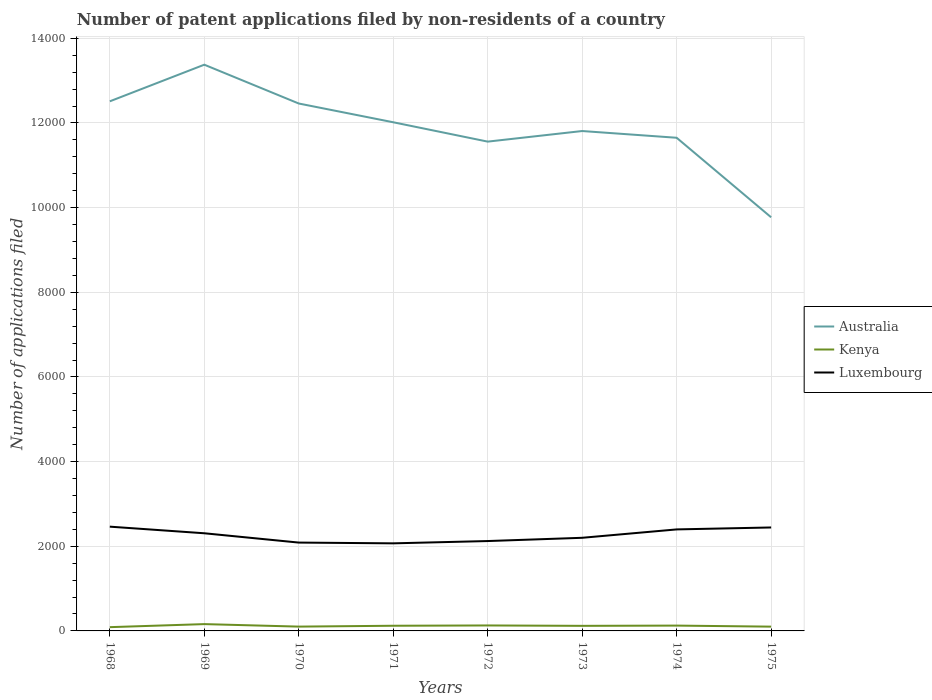Is the number of lines equal to the number of legend labels?
Give a very brief answer. Yes. Across all years, what is the maximum number of applications filed in Australia?
Make the answer very short. 9771. In which year was the number of applications filed in Australia maximum?
Offer a terse response. 1975. What is the difference between the highest and the second highest number of applications filed in Australia?
Make the answer very short. 3605. How many years are there in the graph?
Keep it short and to the point. 8. What is the difference between two consecutive major ticks on the Y-axis?
Give a very brief answer. 2000. Are the values on the major ticks of Y-axis written in scientific E-notation?
Your response must be concise. No. Does the graph contain any zero values?
Offer a very short reply. No. Does the graph contain grids?
Provide a short and direct response. Yes. Where does the legend appear in the graph?
Keep it short and to the point. Center right. How many legend labels are there?
Ensure brevity in your answer.  3. How are the legend labels stacked?
Your answer should be compact. Vertical. What is the title of the graph?
Your response must be concise. Number of patent applications filed by non-residents of a country. Does "Northern Mariana Islands" appear as one of the legend labels in the graph?
Ensure brevity in your answer.  No. What is the label or title of the X-axis?
Provide a succinct answer. Years. What is the label or title of the Y-axis?
Offer a terse response. Number of applications filed. What is the Number of applications filed of Australia in 1968?
Provide a short and direct response. 1.25e+04. What is the Number of applications filed of Kenya in 1968?
Your response must be concise. 89. What is the Number of applications filed of Luxembourg in 1968?
Keep it short and to the point. 2463. What is the Number of applications filed of Australia in 1969?
Ensure brevity in your answer.  1.34e+04. What is the Number of applications filed of Kenya in 1969?
Ensure brevity in your answer.  161. What is the Number of applications filed of Luxembourg in 1969?
Keep it short and to the point. 2307. What is the Number of applications filed of Australia in 1970?
Ensure brevity in your answer.  1.25e+04. What is the Number of applications filed of Kenya in 1970?
Make the answer very short. 102. What is the Number of applications filed of Luxembourg in 1970?
Make the answer very short. 2087. What is the Number of applications filed of Australia in 1971?
Make the answer very short. 1.20e+04. What is the Number of applications filed in Kenya in 1971?
Ensure brevity in your answer.  122. What is the Number of applications filed in Luxembourg in 1971?
Provide a short and direct response. 2069. What is the Number of applications filed of Australia in 1972?
Offer a very short reply. 1.16e+04. What is the Number of applications filed of Kenya in 1972?
Provide a short and direct response. 129. What is the Number of applications filed of Luxembourg in 1972?
Offer a very short reply. 2123. What is the Number of applications filed of Australia in 1973?
Provide a short and direct response. 1.18e+04. What is the Number of applications filed in Kenya in 1973?
Your answer should be compact. 120. What is the Number of applications filed of Luxembourg in 1973?
Your answer should be very brief. 2200. What is the Number of applications filed in Australia in 1974?
Offer a very short reply. 1.16e+04. What is the Number of applications filed in Kenya in 1974?
Offer a very short reply. 126. What is the Number of applications filed of Luxembourg in 1974?
Make the answer very short. 2398. What is the Number of applications filed in Australia in 1975?
Give a very brief answer. 9771. What is the Number of applications filed of Kenya in 1975?
Your response must be concise. 101. What is the Number of applications filed in Luxembourg in 1975?
Ensure brevity in your answer.  2444. Across all years, what is the maximum Number of applications filed of Australia?
Your response must be concise. 1.34e+04. Across all years, what is the maximum Number of applications filed in Kenya?
Offer a very short reply. 161. Across all years, what is the maximum Number of applications filed in Luxembourg?
Offer a very short reply. 2463. Across all years, what is the minimum Number of applications filed of Australia?
Your answer should be compact. 9771. Across all years, what is the minimum Number of applications filed of Kenya?
Your response must be concise. 89. Across all years, what is the minimum Number of applications filed in Luxembourg?
Your answer should be very brief. 2069. What is the total Number of applications filed in Australia in the graph?
Offer a terse response. 9.52e+04. What is the total Number of applications filed of Kenya in the graph?
Make the answer very short. 950. What is the total Number of applications filed in Luxembourg in the graph?
Your response must be concise. 1.81e+04. What is the difference between the Number of applications filed in Australia in 1968 and that in 1969?
Offer a terse response. -865. What is the difference between the Number of applications filed in Kenya in 1968 and that in 1969?
Ensure brevity in your answer.  -72. What is the difference between the Number of applications filed in Luxembourg in 1968 and that in 1969?
Ensure brevity in your answer.  156. What is the difference between the Number of applications filed of Australia in 1968 and that in 1970?
Your response must be concise. 52. What is the difference between the Number of applications filed in Kenya in 1968 and that in 1970?
Ensure brevity in your answer.  -13. What is the difference between the Number of applications filed in Luxembourg in 1968 and that in 1970?
Keep it short and to the point. 376. What is the difference between the Number of applications filed of Australia in 1968 and that in 1971?
Provide a succinct answer. 495. What is the difference between the Number of applications filed in Kenya in 1968 and that in 1971?
Ensure brevity in your answer.  -33. What is the difference between the Number of applications filed of Luxembourg in 1968 and that in 1971?
Your answer should be very brief. 394. What is the difference between the Number of applications filed of Australia in 1968 and that in 1972?
Provide a short and direct response. 952. What is the difference between the Number of applications filed of Luxembourg in 1968 and that in 1972?
Provide a succinct answer. 340. What is the difference between the Number of applications filed of Australia in 1968 and that in 1973?
Make the answer very short. 702. What is the difference between the Number of applications filed in Kenya in 1968 and that in 1973?
Provide a short and direct response. -31. What is the difference between the Number of applications filed of Luxembourg in 1968 and that in 1973?
Offer a very short reply. 263. What is the difference between the Number of applications filed of Australia in 1968 and that in 1974?
Your answer should be compact. 861. What is the difference between the Number of applications filed of Kenya in 1968 and that in 1974?
Provide a short and direct response. -37. What is the difference between the Number of applications filed of Luxembourg in 1968 and that in 1974?
Offer a terse response. 65. What is the difference between the Number of applications filed of Australia in 1968 and that in 1975?
Offer a terse response. 2740. What is the difference between the Number of applications filed of Luxembourg in 1968 and that in 1975?
Provide a short and direct response. 19. What is the difference between the Number of applications filed in Australia in 1969 and that in 1970?
Offer a terse response. 917. What is the difference between the Number of applications filed in Kenya in 1969 and that in 1970?
Provide a short and direct response. 59. What is the difference between the Number of applications filed in Luxembourg in 1969 and that in 1970?
Your answer should be compact. 220. What is the difference between the Number of applications filed in Australia in 1969 and that in 1971?
Your response must be concise. 1360. What is the difference between the Number of applications filed of Kenya in 1969 and that in 1971?
Your answer should be very brief. 39. What is the difference between the Number of applications filed of Luxembourg in 1969 and that in 1971?
Your answer should be very brief. 238. What is the difference between the Number of applications filed in Australia in 1969 and that in 1972?
Your answer should be compact. 1817. What is the difference between the Number of applications filed in Kenya in 1969 and that in 1972?
Your answer should be compact. 32. What is the difference between the Number of applications filed in Luxembourg in 1969 and that in 1972?
Give a very brief answer. 184. What is the difference between the Number of applications filed of Australia in 1969 and that in 1973?
Ensure brevity in your answer.  1567. What is the difference between the Number of applications filed in Luxembourg in 1969 and that in 1973?
Provide a succinct answer. 107. What is the difference between the Number of applications filed in Australia in 1969 and that in 1974?
Provide a succinct answer. 1726. What is the difference between the Number of applications filed in Luxembourg in 1969 and that in 1974?
Provide a succinct answer. -91. What is the difference between the Number of applications filed of Australia in 1969 and that in 1975?
Keep it short and to the point. 3605. What is the difference between the Number of applications filed of Luxembourg in 1969 and that in 1975?
Make the answer very short. -137. What is the difference between the Number of applications filed of Australia in 1970 and that in 1971?
Your answer should be very brief. 443. What is the difference between the Number of applications filed in Kenya in 1970 and that in 1971?
Keep it short and to the point. -20. What is the difference between the Number of applications filed of Australia in 1970 and that in 1972?
Keep it short and to the point. 900. What is the difference between the Number of applications filed of Luxembourg in 1970 and that in 1972?
Give a very brief answer. -36. What is the difference between the Number of applications filed of Australia in 1970 and that in 1973?
Make the answer very short. 650. What is the difference between the Number of applications filed in Luxembourg in 1970 and that in 1973?
Your answer should be compact. -113. What is the difference between the Number of applications filed in Australia in 1970 and that in 1974?
Your answer should be very brief. 809. What is the difference between the Number of applications filed in Luxembourg in 1970 and that in 1974?
Offer a terse response. -311. What is the difference between the Number of applications filed in Australia in 1970 and that in 1975?
Give a very brief answer. 2688. What is the difference between the Number of applications filed of Kenya in 1970 and that in 1975?
Your answer should be compact. 1. What is the difference between the Number of applications filed of Luxembourg in 1970 and that in 1975?
Offer a terse response. -357. What is the difference between the Number of applications filed of Australia in 1971 and that in 1972?
Offer a terse response. 457. What is the difference between the Number of applications filed of Luxembourg in 1971 and that in 1972?
Offer a terse response. -54. What is the difference between the Number of applications filed in Australia in 1971 and that in 1973?
Provide a succinct answer. 207. What is the difference between the Number of applications filed in Kenya in 1971 and that in 1973?
Offer a terse response. 2. What is the difference between the Number of applications filed of Luxembourg in 1971 and that in 1973?
Your answer should be very brief. -131. What is the difference between the Number of applications filed of Australia in 1971 and that in 1974?
Your response must be concise. 366. What is the difference between the Number of applications filed in Luxembourg in 1971 and that in 1974?
Offer a very short reply. -329. What is the difference between the Number of applications filed in Australia in 1971 and that in 1975?
Keep it short and to the point. 2245. What is the difference between the Number of applications filed in Luxembourg in 1971 and that in 1975?
Keep it short and to the point. -375. What is the difference between the Number of applications filed in Australia in 1972 and that in 1973?
Ensure brevity in your answer.  -250. What is the difference between the Number of applications filed of Kenya in 1972 and that in 1973?
Your response must be concise. 9. What is the difference between the Number of applications filed in Luxembourg in 1972 and that in 1973?
Your response must be concise. -77. What is the difference between the Number of applications filed of Australia in 1972 and that in 1974?
Your answer should be very brief. -91. What is the difference between the Number of applications filed in Luxembourg in 1972 and that in 1974?
Provide a succinct answer. -275. What is the difference between the Number of applications filed in Australia in 1972 and that in 1975?
Offer a very short reply. 1788. What is the difference between the Number of applications filed in Luxembourg in 1972 and that in 1975?
Make the answer very short. -321. What is the difference between the Number of applications filed of Australia in 1973 and that in 1974?
Provide a short and direct response. 159. What is the difference between the Number of applications filed in Luxembourg in 1973 and that in 1974?
Your answer should be compact. -198. What is the difference between the Number of applications filed of Australia in 1973 and that in 1975?
Offer a terse response. 2038. What is the difference between the Number of applications filed of Luxembourg in 1973 and that in 1975?
Provide a short and direct response. -244. What is the difference between the Number of applications filed of Australia in 1974 and that in 1975?
Offer a terse response. 1879. What is the difference between the Number of applications filed in Kenya in 1974 and that in 1975?
Ensure brevity in your answer.  25. What is the difference between the Number of applications filed of Luxembourg in 1974 and that in 1975?
Make the answer very short. -46. What is the difference between the Number of applications filed of Australia in 1968 and the Number of applications filed of Kenya in 1969?
Your response must be concise. 1.24e+04. What is the difference between the Number of applications filed of Australia in 1968 and the Number of applications filed of Luxembourg in 1969?
Ensure brevity in your answer.  1.02e+04. What is the difference between the Number of applications filed of Kenya in 1968 and the Number of applications filed of Luxembourg in 1969?
Your answer should be compact. -2218. What is the difference between the Number of applications filed in Australia in 1968 and the Number of applications filed in Kenya in 1970?
Your response must be concise. 1.24e+04. What is the difference between the Number of applications filed in Australia in 1968 and the Number of applications filed in Luxembourg in 1970?
Ensure brevity in your answer.  1.04e+04. What is the difference between the Number of applications filed of Kenya in 1968 and the Number of applications filed of Luxembourg in 1970?
Your answer should be compact. -1998. What is the difference between the Number of applications filed in Australia in 1968 and the Number of applications filed in Kenya in 1971?
Ensure brevity in your answer.  1.24e+04. What is the difference between the Number of applications filed of Australia in 1968 and the Number of applications filed of Luxembourg in 1971?
Provide a short and direct response. 1.04e+04. What is the difference between the Number of applications filed of Kenya in 1968 and the Number of applications filed of Luxembourg in 1971?
Offer a terse response. -1980. What is the difference between the Number of applications filed in Australia in 1968 and the Number of applications filed in Kenya in 1972?
Your response must be concise. 1.24e+04. What is the difference between the Number of applications filed of Australia in 1968 and the Number of applications filed of Luxembourg in 1972?
Offer a terse response. 1.04e+04. What is the difference between the Number of applications filed in Kenya in 1968 and the Number of applications filed in Luxembourg in 1972?
Provide a short and direct response. -2034. What is the difference between the Number of applications filed in Australia in 1968 and the Number of applications filed in Kenya in 1973?
Offer a very short reply. 1.24e+04. What is the difference between the Number of applications filed in Australia in 1968 and the Number of applications filed in Luxembourg in 1973?
Make the answer very short. 1.03e+04. What is the difference between the Number of applications filed of Kenya in 1968 and the Number of applications filed of Luxembourg in 1973?
Keep it short and to the point. -2111. What is the difference between the Number of applications filed in Australia in 1968 and the Number of applications filed in Kenya in 1974?
Give a very brief answer. 1.24e+04. What is the difference between the Number of applications filed of Australia in 1968 and the Number of applications filed of Luxembourg in 1974?
Ensure brevity in your answer.  1.01e+04. What is the difference between the Number of applications filed in Kenya in 1968 and the Number of applications filed in Luxembourg in 1974?
Offer a terse response. -2309. What is the difference between the Number of applications filed of Australia in 1968 and the Number of applications filed of Kenya in 1975?
Provide a short and direct response. 1.24e+04. What is the difference between the Number of applications filed of Australia in 1968 and the Number of applications filed of Luxembourg in 1975?
Keep it short and to the point. 1.01e+04. What is the difference between the Number of applications filed in Kenya in 1968 and the Number of applications filed in Luxembourg in 1975?
Provide a succinct answer. -2355. What is the difference between the Number of applications filed in Australia in 1969 and the Number of applications filed in Kenya in 1970?
Give a very brief answer. 1.33e+04. What is the difference between the Number of applications filed in Australia in 1969 and the Number of applications filed in Luxembourg in 1970?
Ensure brevity in your answer.  1.13e+04. What is the difference between the Number of applications filed of Kenya in 1969 and the Number of applications filed of Luxembourg in 1970?
Make the answer very short. -1926. What is the difference between the Number of applications filed of Australia in 1969 and the Number of applications filed of Kenya in 1971?
Provide a short and direct response. 1.33e+04. What is the difference between the Number of applications filed of Australia in 1969 and the Number of applications filed of Luxembourg in 1971?
Provide a short and direct response. 1.13e+04. What is the difference between the Number of applications filed of Kenya in 1969 and the Number of applications filed of Luxembourg in 1971?
Your response must be concise. -1908. What is the difference between the Number of applications filed of Australia in 1969 and the Number of applications filed of Kenya in 1972?
Your answer should be compact. 1.32e+04. What is the difference between the Number of applications filed of Australia in 1969 and the Number of applications filed of Luxembourg in 1972?
Give a very brief answer. 1.13e+04. What is the difference between the Number of applications filed in Kenya in 1969 and the Number of applications filed in Luxembourg in 1972?
Give a very brief answer. -1962. What is the difference between the Number of applications filed in Australia in 1969 and the Number of applications filed in Kenya in 1973?
Give a very brief answer. 1.33e+04. What is the difference between the Number of applications filed of Australia in 1969 and the Number of applications filed of Luxembourg in 1973?
Give a very brief answer. 1.12e+04. What is the difference between the Number of applications filed in Kenya in 1969 and the Number of applications filed in Luxembourg in 1973?
Give a very brief answer. -2039. What is the difference between the Number of applications filed of Australia in 1969 and the Number of applications filed of Kenya in 1974?
Provide a succinct answer. 1.32e+04. What is the difference between the Number of applications filed in Australia in 1969 and the Number of applications filed in Luxembourg in 1974?
Provide a short and direct response. 1.10e+04. What is the difference between the Number of applications filed of Kenya in 1969 and the Number of applications filed of Luxembourg in 1974?
Ensure brevity in your answer.  -2237. What is the difference between the Number of applications filed in Australia in 1969 and the Number of applications filed in Kenya in 1975?
Your answer should be compact. 1.33e+04. What is the difference between the Number of applications filed in Australia in 1969 and the Number of applications filed in Luxembourg in 1975?
Provide a short and direct response. 1.09e+04. What is the difference between the Number of applications filed in Kenya in 1969 and the Number of applications filed in Luxembourg in 1975?
Provide a succinct answer. -2283. What is the difference between the Number of applications filed in Australia in 1970 and the Number of applications filed in Kenya in 1971?
Your response must be concise. 1.23e+04. What is the difference between the Number of applications filed of Australia in 1970 and the Number of applications filed of Luxembourg in 1971?
Provide a short and direct response. 1.04e+04. What is the difference between the Number of applications filed in Kenya in 1970 and the Number of applications filed in Luxembourg in 1971?
Provide a short and direct response. -1967. What is the difference between the Number of applications filed of Australia in 1970 and the Number of applications filed of Kenya in 1972?
Provide a short and direct response. 1.23e+04. What is the difference between the Number of applications filed of Australia in 1970 and the Number of applications filed of Luxembourg in 1972?
Make the answer very short. 1.03e+04. What is the difference between the Number of applications filed of Kenya in 1970 and the Number of applications filed of Luxembourg in 1972?
Ensure brevity in your answer.  -2021. What is the difference between the Number of applications filed of Australia in 1970 and the Number of applications filed of Kenya in 1973?
Give a very brief answer. 1.23e+04. What is the difference between the Number of applications filed in Australia in 1970 and the Number of applications filed in Luxembourg in 1973?
Your answer should be compact. 1.03e+04. What is the difference between the Number of applications filed in Kenya in 1970 and the Number of applications filed in Luxembourg in 1973?
Offer a very short reply. -2098. What is the difference between the Number of applications filed of Australia in 1970 and the Number of applications filed of Kenya in 1974?
Your response must be concise. 1.23e+04. What is the difference between the Number of applications filed of Australia in 1970 and the Number of applications filed of Luxembourg in 1974?
Your answer should be compact. 1.01e+04. What is the difference between the Number of applications filed in Kenya in 1970 and the Number of applications filed in Luxembourg in 1974?
Your answer should be compact. -2296. What is the difference between the Number of applications filed of Australia in 1970 and the Number of applications filed of Kenya in 1975?
Keep it short and to the point. 1.24e+04. What is the difference between the Number of applications filed in Australia in 1970 and the Number of applications filed in Luxembourg in 1975?
Provide a succinct answer. 1.00e+04. What is the difference between the Number of applications filed in Kenya in 1970 and the Number of applications filed in Luxembourg in 1975?
Provide a succinct answer. -2342. What is the difference between the Number of applications filed in Australia in 1971 and the Number of applications filed in Kenya in 1972?
Give a very brief answer. 1.19e+04. What is the difference between the Number of applications filed in Australia in 1971 and the Number of applications filed in Luxembourg in 1972?
Your answer should be compact. 9893. What is the difference between the Number of applications filed of Kenya in 1971 and the Number of applications filed of Luxembourg in 1972?
Offer a terse response. -2001. What is the difference between the Number of applications filed of Australia in 1971 and the Number of applications filed of Kenya in 1973?
Give a very brief answer. 1.19e+04. What is the difference between the Number of applications filed in Australia in 1971 and the Number of applications filed in Luxembourg in 1973?
Keep it short and to the point. 9816. What is the difference between the Number of applications filed of Kenya in 1971 and the Number of applications filed of Luxembourg in 1973?
Make the answer very short. -2078. What is the difference between the Number of applications filed of Australia in 1971 and the Number of applications filed of Kenya in 1974?
Keep it short and to the point. 1.19e+04. What is the difference between the Number of applications filed in Australia in 1971 and the Number of applications filed in Luxembourg in 1974?
Your answer should be compact. 9618. What is the difference between the Number of applications filed of Kenya in 1971 and the Number of applications filed of Luxembourg in 1974?
Offer a very short reply. -2276. What is the difference between the Number of applications filed in Australia in 1971 and the Number of applications filed in Kenya in 1975?
Your answer should be compact. 1.19e+04. What is the difference between the Number of applications filed of Australia in 1971 and the Number of applications filed of Luxembourg in 1975?
Give a very brief answer. 9572. What is the difference between the Number of applications filed of Kenya in 1971 and the Number of applications filed of Luxembourg in 1975?
Make the answer very short. -2322. What is the difference between the Number of applications filed of Australia in 1972 and the Number of applications filed of Kenya in 1973?
Provide a short and direct response. 1.14e+04. What is the difference between the Number of applications filed in Australia in 1972 and the Number of applications filed in Luxembourg in 1973?
Make the answer very short. 9359. What is the difference between the Number of applications filed of Kenya in 1972 and the Number of applications filed of Luxembourg in 1973?
Provide a short and direct response. -2071. What is the difference between the Number of applications filed in Australia in 1972 and the Number of applications filed in Kenya in 1974?
Your answer should be very brief. 1.14e+04. What is the difference between the Number of applications filed of Australia in 1972 and the Number of applications filed of Luxembourg in 1974?
Ensure brevity in your answer.  9161. What is the difference between the Number of applications filed in Kenya in 1972 and the Number of applications filed in Luxembourg in 1974?
Your answer should be very brief. -2269. What is the difference between the Number of applications filed of Australia in 1972 and the Number of applications filed of Kenya in 1975?
Ensure brevity in your answer.  1.15e+04. What is the difference between the Number of applications filed in Australia in 1972 and the Number of applications filed in Luxembourg in 1975?
Ensure brevity in your answer.  9115. What is the difference between the Number of applications filed of Kenya in 1972 and the Number of applications filed of Luxembourg in 1975?
Ensure brevity in your answer.  -2315. What is the difference between the Number of applications filed in Australia in 1973 and the Number of applications filed in Kenya in 1974?
Offer a terse response. 1.17e+04. What is the difference between the Number of applications filed of Australia in 1973 and the Number of applications filed of Luxembourg in 1974?
Offer a terse response. 9411. What is the difference between the Number of applications filed in Kenya in 1973 and the Number of applications filed in Luxembourg in 1974?
Offer a very short reply. -2278. What is the difference between the Number of applications filed in Australia in 1973 and the Number of applications filed in Kenya in 1975?
Keep it short and to the point. 1.17e+04. What is the difference between the Number of applications filed of Australia in 1973 and the Number of applications filed of Luxembourg in 1975?
Your answer should be compact. 9365. What is the difference between the Number of applications filed in Kenya in 1973 and the Number of applications filed in Luxembourg in 1975?
Your answer should be compact. -2324. What is the difference between the Number of applications filed in Australia in 1974 and the Number of applications filed in Kenya in 1975?
Ensure brevity in your answer.  1.15e+04. What is the difference between the Number of applications filed in Australia in 1974 and the Number of applications filed in Luxembourg in 1975?
Ensure brevity in your answer.  9206. What is the difference between the Number of applications filed in Kenya in 1974 and the Number of applications filed in Luxembourg in 1975?
Provide a short and direct response. -2318. What is the average Number of applications filed in Australia per year?
Ensure brevity in your answer.  1.19e+04. What is the average Number of applications filed in Kenya per year?
Offer a terse response. 118.75. What is the average Number of applications filed of Luxembourg per year?
Give a very brief answer. 2261.38. In the year 1968, what is the difference between the Number of applications filed of Australia and Number of applications filed of Kenya?
Provide a short and direct response. 1.24e+04. In the year 1968, what is the difference between the Number of applications filed in Australia and Number of applications filed in Luxembourg?
Offer a very short reply. 1.00e+04. In the year 1968, what is the difference between the Number of applications filed of Kenya and Number of applications filed of Luxembourg?
Provide a short and direct response. -2374. In the year 1969, what is the difference between the Number of applications filed in Australia and Number of applications filed in Kenya?
Offer a terse response. 1.32e+04. In the year 1969, what is the difference between the Number of applications filed in Australia and Number of applications filed in Luxembourg?
Keep it short and to the point. 1.11e+04. In the year 1969, what is the difference between the Number of applications filed of Kenya and Number of applications filed of Luxembourg?
Your response must be concise. -2146. In the year 1970, what is the difference between the Number of applications filed of Australia and Number of applications filed of Kenya?
Make the answer very short. 1.24e+04. In the year 1970, what is the difference between the Number of applications filed in Australia and Number of applications filed in Luxembourg?
Ensure brevity in your answer.  1.04e+04. In the year 1970, what is the difference between the Number of applications filed of Kenya and Number of applications filed of Luxembourg?
Offer a very short reply. -1985. In the year 1971, what is the difference between the Number of applications filed in Australia and Number of applications filed in Kenya?
Your answer should be compact. 1.19e+04. In the year 1971, what is the difference between the Number of applications filed of Australia and Number of applications filed of Luxembourg?
Give a very brief answer. 9947. In the year 1971, what is the difference between the Number of applications filed in Kenya and Number of applications filed in Luxembourg?
Your response must be concise. -1947. In the year 1972, what is the difference between the Number of applications filed in Australia and Number of applications filed in Kenya?
Your answer should be compact. 1.14e+04. In the year 1972, what is the difference between the Number of applications filed of Australia and Number of applications filed of Luxembourg?
Ensure brevity in your answer.  9436. In the year 1972, what is the difference between the Number of applications filed in Kenya and Number of applications filed in Luxembourg?
Your answer should be compact. -1994. In the year 1973, what is the difference between the Number of applications filed in Australia and Number of applications filed in Kenya?
Offer a terse response. 1.17e+04. In the year 1973, what is the difference between the Number of applications filed in Australia and Number of applications filed in Luxembourg?
Provide a succinct answer. 9609. In the year 1973, what is the difference between the Number of applications filed in Kenya and Number of applications filed in Luxembourg?
Provide a succinct answer. -2080. In the year 1974, what is the difference between the Number of applications filed of Australia and Number of applications filed of Kenya?
Your answer should be compact. 1.15e+04. In the year 1974, what is the difference between the Number of applications filed in Australia and Number of applications filed in Luxembourg?
Keep it short and to the point. 9252. In the year 1974, what is the difference between the Number of applications filed of Kenya and Number of applications filed of Luxembourg?
Provide a short and direct response. -2272. In the year 1975, what is the difference between the Number of applications filed in Australia and Number of applications filed in Kenya?
Give a very brief answer. 9670. In the year 1975, what is the difference between the Number of applications filed of Australia and Number of applications filed of Luxembourg?
Offer a very short reply. 7327. In the year 1975, what is the difference between the Number of applications filed in Kenya and Number of applications filed in Luxembourg?
Offer a terse response. -2343. What is the ratio of the Number of applications filed of Australia in 1968 to that in 1969?
Your answer should be compact. 0.94. What is the ratio of the Number of applications filed in Kenya in 1968 to that in 1969?
Make the answer very short. 0.55. What is the ratio of the Number of applications filed of Luxembourg in 1968 to that in 1969?
Your response must be concise. 1.07. What is the ratio of the Number of applications filed in Kenya in 1968 to that in 1970?
Provide a succinct answer. 0.87. What is the ratio of the Number of applications filed of Luxembourg in 1968 to that in 1970?
Your answer should be compact. 1.18. What is the ratio of the Number of applications filed of Australia in 1968 to that in 1971?
Offer a very short reply. 1.04. What is the ratio of the Number of applications filed of Kenya in 1968 to that in 1971?
Give a very brief answer. 0.73. What is the ratio of the Number of applications filed in Luxembourg in 1968 to that in 1971?
Provide a succinct answer. 1.19. What is the ratio of the Number of applications filed in Australia in 1968 to that in 1972?
Provide a short and direct response. 1.08. What is the ratio of the Number of applications filed of Kenya in 1968 to that in 1972?
Provide a short and direct response. 0.69. What is the ratio of the Number of applications filed of Luxembourg in 1968 to that in 1972?
Ensure brevity in your answer.  1.16. What is the ratio of the Number of applications filed in Australia in 1968 to that in 1973?
Ensure brevity in your answer.  1.06. What is the ratio of the Number of applications filed of Kenya in 1968 to that in 1973?
Make the answer very short. 0.74. What is the ratio of the Number of applications filed in Luxembourg in 1968 to that in 1973?
Your response must be concise. 1.12. What is the ratio of the Number of applications filed in Australia in 1968 to that in 1974?
Your answer should be compact. 1.07. What is the ratio of the Number of applications filed of Kenya in 1968 to that in 1974?
Keep it short and to the point. 0.71. What is the ratio of the Number of applications filed in Luxembourg in 1968 to that in 1974?
Give a very brief answer. 1.03. What is the ratio of the Number of applications filed of Australia in 1968 to that in 1975?
Provide a short and direct response. 1.28. What is the ratio of the Number of applications filed of Kenya in 1968 to that in 1975?
Ensure brevity in your answer.  0.88. What is the ratio of the Number of applications filed in Australia in 1969 to that in 1970?
Give a very brief answer. 1.07. What is the ratio of the Number of applications filed of Kenya in 1969 to that in 1970?
Your answer should be compact. 1.58. What is the ratio of the Number of applications filed in Luxembourg in 1969 to that in 1970?
Give a very brief answer. 1.11. What is the ratio of the Number of applications filed of Australia in 1969 to that in 1971?
Your answer should be very brief. 1.11. What is the ratio of the Number of applications filed in Kenya in 1969 to that in 1971?
Offer a very short reply. 1.32. What is the ratio of the Number of applications filed of Luxembourg in 1969 to that in 1971?
Provide a short and direct response. 1.11. What is the ratio of the Number of applications filed of Australia in 1969 to that in 1972?
Your answer should be very brief. 1.16. What is the ratio of the Number of applications filed in Kenya in 1969 to that in 1972?
Your response must be concise. 1.25. What is the ratio of the Number of applications filed in Luxembourg in 1969 to that in 1972?
Your answer should be compact. 1.09. What is the ratio of the Number of applications filed in Australia in 1969 to that in 1973?
Your response must be concise. 1.13. What is the ratio of the Number of applications filed of Kenya in 1969 to that in 1973?
Ensure brevity in your answer.  1.34. What is the ratio of the Number of applications filed of Luxembourg in 1969 to that in 1973?
Provide a succinct answer. 1.05. What is the ratio of the Number of applications filed of Australia in 1969 to that in 1974?
Your response must be concise. 1.15. What is the ratio of the Number of applications filed in Kenya in 1969 to that in 1974?
Provide a succinct answer. 1.28. What is the ratio of the Number of applications filed of Luxembourg in 1969 to that in 1974?
Provide a succinct answer. 0.96. What is the ratio of the Number of applications filed in Australia in 1969 to that in 1975?
Make the answer very short. 1.37. What is the ratio of the Number of applications filed in Kenya in 1969 to that in 1975?
Keep it short and to the point. 1.59. What is the ratio of the Number of applications filed in Luxembourg in 1969 to that in 1975?
Make the answer very short. 0.94. What is the ratio of the Number of applications filed in Australia in 1970 to that in 1971?
Your answer should be compact. 1.04. What is the ratio of the Number of applications filed of Kenya in 1970 to that in 1971?
Provide a short and direct response. 0.84. What is the ratio of the Number of applications filed of Luxembourg in 1970 to that in 1971?
Ensure brevity in your answer.  1.01. What is the ratio of the Number of applications filed of Australia in 1970 to that in 1972?
Provide a succinct answer. 1.08. What is the ratio of the Number of applications filed of Kenya in 1970 to that in 1972?
Provide a short and direct response. 0.79. What is the ratio of the Number of applications filed in Luxembourg in 1970 to that in 1972?
Your response must be concise. 0.98. What is the ratio of the Number of applications filed in Australia in 1970 to that in 1973?
Provide a succinct answer. 1.05. What is the ratio of the Number of applications filed in Luxembourg in 1970 to that in 1973?
Ensure brevity in your answer.  0.95. What is the ratio of the Number of applications filed in Australia in 1970 to that in 1974?
Provide a succinct answer. 1.07. What is the ratio of the Number of applications filed of Kenya in 1970 to that in 1974?
Provide a succinct answer. 0.81. What is the ratio of the Number of applications filed of Luxembourg in 1970 to that in 1974?
Provide a short and direct response. 0.87. What is the ratio of the Number of applications filed in Australia in 1970 to that in 1975?
Your answer should be compact. 1.28. What is the ratio of the Number of applications filed in Kenya in 1970 to that in 1975?
Keep it short and to the point. 1.01. What is the ratio of the Number of applications filed in Luxembourg in 1970 to that in 1975?
Make the answer very short. 0.85. What is the ratio of the Number of applications filed in Australia in 1971 to that in 1972?
Make the answer very short. 1.04. What is the ratio of the Number of applications filed in Kenya in 1971 to that in 1972?
Offer a very short reply. 0.95. What is the ratio of the Number of applications filed of Luxembourg in 1971 to that in 1972?
Ensure brevity in your answer.  0.97. What is the ratio of the Number of applications filed in Australia in 1971 to that in 1973?
Provide a short and direct response. 1.02. What is the ratio of the Number of applications filed of Kenya in 1971 to that in 1973?
Provide a succinct answer. 1.02. What is the ratio of the Number of applications filed of Luxembourg in 1971 to that in 1973?
Give a very brief answer. 0.94. What is the ratio of the Number of applications filed of Australia in 1971 to that in 1974?
Your answer should be very brief. 1.03. What is the ratio of the Number of applications filed of Kenya in 1971 to that in 1974?
Provide a short and direct response. 0.97. What is the ratio of the Number of applications filed of Luxembourg in 1971 to that in 1974?
Ensure brevity in your answer.  0.86. What is the ratio of the Number of applications filed of Australia in 1971 to that in 1975?
Keep it short and to the point. 1.23. What is the ratio of the Number of applications filed of Kenya in 1971 to that in 1975?
Your response must be concise. 1.21. What is the ratio of the Number of applications filed of Luxembourg in 1971 to that in 1975?
Keep it short and to the point. 0.85. What is the ratio of the Number of applications filed in Australia in 1972 to that in 1973?
Your answer should be compact. 0.98. What is the ratio of the Number of applications filed of Kenya in 1972 to that in 1973?
Provide a succinct answer. 1.07. What is the ratio of the Number of applications filed of Kenya in 1972 to that in 1974?
Keep it short and to the point. 1.02. What is the ratio of the Number of applications filed of Luxembourg in 1972 to that in 1974?
Give a very brief answer. 0.89. What is the ratio of the Number of applications filed in Australia in 1972 to that in 1975?
Give a very brief answer. 1.18. What is the ratio of the Number of applications filed of Kenya in 1972 to that in 1975?
Your response must be concise. 1.28. What is the ratio of the Number of applications filed in Luxembourg in 1972 to that in 1975?
Provide a short and direct response. 0.87. What is the ratio of the Number of applications filed in Australia in 1973 to that in 1974?
Give a very brief answer. 1.01. What is the ratio of the Number of applications filed in Luxembourg in 1973 to that in 1974?
Make the answer very short. 0.92. What is the ratio of the Number of applications filed in Australia in 1973 to that in 1975?
Offer a very short reply. 1.21. What is the ratio of the Number of applications filed in Kenya in 1973 to that in 1975?
Give a very brief answer. 1.19. What is the ratio of the Number of applications filed in Luxembourg in 1973 to that in 1975?
Your answer should be compact. 0.9. What is the ratio of the Number of applications filed in Australia in 1974 to that in 1975?
Keep it short and to the point. 1.19. What is the ratio of the Number of applications filed of Kenya in 1974 to that in 1975?
Provide a succinct answer. 1.25. What is the ratio of the Number of applications filed of Luxembourg in 1974 to that in 1975?
Make the answer very short. 0.98. What is the difference between the highest and the second highest Number of applications filed of Australia?
Offer a very short reply. 865. What is the difference between the highest and the second highest Number of applications filed of Kenya?
Offer a very short reply. 32. What is the difference between the highest and the second highest Number of applications filed in Luxembourg?
Your response must be concise. 19. What is the difference between the highest and the lowest Number of applications filed of Australia?
Make the answer very short. 3605. What is the difference between the highest and the lowest Number of applications filed of Luxembourg?
Provide a succinct answer. 394. 